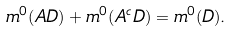<formula> <loc_0><loc_0><loc_500><loc_500>m ^ { 0 } ( A D ) + m ^ { 0 } ( A ^ { c } D ) = m ^ { 0 } ( D ) .</formula> 